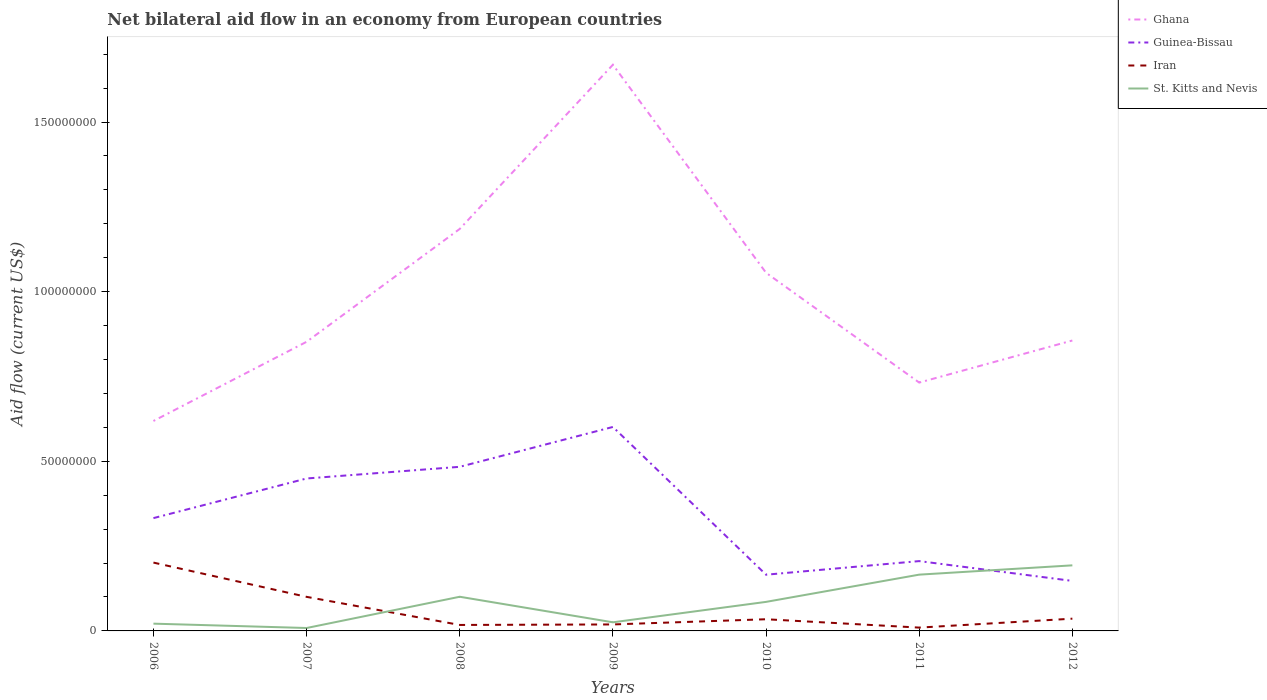How many different coloured lines are there?
Your response must be concise. 4. Does the line corresponding to Iran intersect with the line corresponding to Ghana?
Give a very brief answer. No. Is the number of lines equal to the number of legend labels?
Keep it short and to the point. Yes. Across all years, what is the maximum net bilateral aid flow in Ghana?
Keep it short and to the point. 6.19e+07. In which year was the net bilateral aid flow in Guinea-Bissau maximum?
Offer a very short reply. 2012. What is the total net bilateral aid flow in Iran in the graph?
Keep it short and to the point. -1.70e+06. What is the difference between the highest and the second highest net bilateral aid flow in Ghana?
Your answer should be compact. 1.05e+08. Is the net bilateral aid flow in Iran strictly greater than the net bilateral aid flow in Ghana over the years?
Your response must be concise. Yes. How many lines are there?
Offer a very short reply. 4. What is the difference between two consecutive major ticks on the Y-axis?
Offer a very short reply. 5.00e+07. Where does the legend appear in the graph?
Ensure brevity in your answer.  Top right. How many legend labels are there?
Provide a succinct answer. 4. What is the title of the graph?
Your response must be concise. Net bilateral aid flow in an economy from European countries. Does "Guam" appear as one of the legend labels in the graph?
Offer a very short reply. No. What is the label or title of the X-axis?
Ensure brevity in your answer.  Years. What is the label or title of the Y-axis?
Your answer should be very brief. Aid flow (current US$). What is the Aid flow (current US$) in Ghana in 2006?
Provide a short and direct response. 6.19e+07. What is the Aid flow (current US$) of Guinea-Bissau in 2006?
Make the answer very short. 3.32e+07. What is the Aid flow (current US$) in Iran in 2006?
Offer a very short reply. 2.01e+07. What is the Aid flow (current US$) in St. Kitts and Nevis in 2006?
Keep it short and to the point. 2.14e+06. What is the Aid flow (current US$) in Ghana in 2007?
Make the answer very short. 8.52e+07. What is the Aid flow (current US$) in Guinea-Bissau in 2007?
Make the answer very short. 4.49e+07. What is the Aid flow (current US$) of Iran in 2007?
Give a very brief answer. 1.00e+07. What is the Aid flow (current US$) of St. Kitts and Nevis in 2007?
Offer a terse response. 8.60e+05. What is the Aid flow (current US$) in Ghana in 2008?
Make the answer very short. 1.18e+08. What is the Aid flow (current US$) in Guinea-Bissau in 2008?
Provide a succinct answer. 4.84e+07. What is the Aid flow (current US$) in Iran in 2008?
Make the answer very short. 1.76e+06. What is the Aid flow (current US$) of St. Kitts and Nevis in 2008?
Offer a very short reply. 1.01e+07. What is the Aid flow (current US$) in Ghana in 2009?
Give a very brief answer. 1.67e+08. What is the Aid flow (current US$) of Guinea-Bissau in 2009?
Your answer should be compact. 6.01e+07. What is the Aid flow (current US$) of Iran in 2009?
Your response must be concise. 1.91e+06. What is the Aid flow (current US$) of St. Kitts and Nevis in 2009?
Provide a succinct answer. 2.54e+06. What is the Aid flow (current US$) of Ghana in 2010?
Offer a very short reply. 1.06e+08. What is the Aid flow (current US$) in Guinea-Bissau in 2010?
Offer a very short reply. 1.66e+07. What is the Aid flow (current US$) in Iran in 2010?
Keep it short and to the point. 3.44e+06. What is the Aid flow (current US$) of St. Kitts and Nevis in 2010?
Offer a terse response. 8.56e+06. What is the Aid flow (current US$) in Ghana in 2011?
Provide a short and direct response. 7.32e+07. What is the Aid flow (current US$) in Guinea-Bissau in 2011?
Make the answer very short. 2.06e+07. What is the Aid flow (current US$) in Iran in 2011?
Give a very brief answer. 9.80e+05. What is the Aid flow (current US$) in St. Kitts and Nevis in 2011?
Keep it short and to the point. 1.66e+07. What is the Aid flow (current US$) of Ghana in 2012?
Make the answer very short. 8.56e+07. What is the Aid flow (current US$) of Guinea-Bissau in 2012?
Make the answer very short. 1.47e+07. What is the Aid flow (current US$) in Iran in 2012?
Offer a terse response. 3.61e+06. What is the Aid flow (current US$) of St. Kitts and Nevis in 2012?
Make the answer very short. 1.93e+07. Across all years, what is the maximum Aid flow (current US$) in Ghana?
Provide a short and direct response. 1.67e+08. Across all years, what is the maximum Aid flow (current US$) of Guinea-Bissau?
Make the answer very short. 6.01e+07. Across all years, what is the maximum Aid flow (current US$) of Iran?
Your response must be concise. 2.01e+07. Across all years, what is the maximum Aid flow (current US$) in St. Kitts and Nevis?
Your answer should be compact. 1.93e+07. Across all years, what is the minimum Aid flow (current US$) of Ghana?
Give a very brief answer. 6.19e+07. Across all years, what is the minimum Aid flow (current US$) of Guinea-Bissau?
Provide a short and direct response. 1.47e+07. Across all years, what is the minimum Aid flow (current US$) of Iran?
Offer a very short reply. 9.80e+05. Across all years, what is the minimum Aid flow (current US$) in St. Kitts and Nevis?
Offer a very short reply. 8.60e+05. What is the total Aid flow (current US$) in Ghana in the graph?
Provide a short and direct response. 6.97e+08. What is the total Aid flow (current US$) in Guinea-Bissau in the graph?
Your response must be concise. 2.39e+08. What is the total Aid flow (current US$) of Iran in the graph?
Offer a terse response. 4.19e+07. What is the total Aid flow (current US$) of St. Kitts and Nevis in the graph?
Your answer should be compact. 6.01e+07. What is the difference between the Aid flow (current US$) in Ghana in 2006 and that in 2007?
Provide a short and direct response. -2.33e+07. What is the difference between the Aid flow (current US$) in Guinea-Bissau in 2006 and that in 2007?
Make the answer very short. -1.17e+07. What is the difference between the Aid flow (current US$) in Iran in 2006 and that in 2007?
Your answer should be compact. 1.01e+07. What is the difference between the Aid flow (current US$) in St. Kitts and Nevis in 2006 and that in 2007?
Provide a succinct answer. 1.28e+06. What is the difference between the Aid flow (current US$) in Ghana in 2006 and that in 2008?
Provide a short and direct response. -5.66e+07. What is the difference between the Aid flow (current US$) in Guinea-Bissau in 2006 and that in 2008?
Your response must be concise. -1.51e+07. What is the difference between the Aid flow (current US$) of Iran in 2006 and that in 2008?
Give a very brief answer. 1.84e+07. What is the difference between the Aid flow (current US$) of St. Kitts and Nevis in 2006 and that in 2008?
Provide a succinct answer. -7.93e+06. What is the difference between the Aid flow (current US$) in Ghana in 2006 and that in 2009?
Your response must be concise. -1.05e+08. What is the difference between the Aid flow (current US$) in Guinea-Bissau in 2006 and that in 2009?
Give a very brief answer. -2.69e+07. What is the difference between the Aid flow (current US$) of Iran in 2006 and that in 2009?
Give a very brief answer. 1.82e+07. What is the difference between the Aid flow (current US$) of St. Kitts and Nevis in 2006 and that in 2009?
Keep it short and to the point. -4.00e+05. What is the difference between the Aid flow (current US$) of Ghana in 2006 and that in 2010?
Offer a terse response. -4.37e+07. What is the difference between the Aid flow (current US$) in Guinea-Bissau in 2006 and that in 2010?
Ensure brevity in your answer.  1.67e+07. What is the difference between the Aid flow (current US$) in Iran in 2006 and that in 2010?
Provide a succinct answer. 1.67e+07. What is the difference between the Aid flow (current US$) of St. Kitts and Nevis in 2006 and that in 2010?
Ensure brevity in your answer.  -6.42e+06. What is the difference between the Aid flow (current US$) in Ghana in 2006 and that in 2011?
Your response must be concise. -1.13e+07. What is the difference between the Aid flow (current US$) in Guinea-Bissau in 2006 and that in 2011?
Provide a succinct answer. 1.27e+07. What is the difference between the Aid flow (current US$) of Iran in 2006 and that in 2011?
Your answer should be very brief. 1.92e+07. What is the difference between the Aid flow (current US$) of St. Kitts and Nevis in 2006 and that in 2011?
Give a very brief answer. -1.44e+07. What is the difference between the Aid flow (current US$) in Ghana in 2006 and that in 2012?
Offer a terse response. -2.37e+07. What is the difference between the Aid flow (current US$) in Guinea-Bissau in 2006 and that in 2012?
Give a very brief answer. 1.85e+07. What is the difference between the Aid flow (current US$) in Iran in 2006 and that in 2012?
Your answer should be very brief. 1.65e+07. What is the difference between the Aid flow (current US$) in St. Kitts and Nevis in 2006 and that in 2012?
Make the answer very short. -1.72e+07. What is the difference between the Aid flow (current US$) in Ghana in 2007 and that in 2008?
Your answer should be very brief. -3.33e+07. What is the difference between the Aid flow (current US$) of Guinea-Bissau in 2007 and that in 2008?
Your response must be concise. -3.44e+06. What is the difference between the Aid flow (current US$) in Iran in 2007 and that in 2008?
Keep it short and to the point. 8.28e+06. What is the difference between the Aid flow (current US$) of St. Kitts and Nevis in 2007 and that in 2008?
Your answer should be compact. -9.21e+06. What is the difference between the Aid flow (current US$) of Ghana in 2007 and that in 2009?
Ensure brevity in your answer.  -8.17e+07. What is the difference between the Aid flow (current US$) of Guinea-Bissau in 2007 and that in 2009?
Ensure brevity in your answer.  -1.52e+07. What is the difference between the Aid flow (current US$) of Iran in 2007 and that in 2009?
Your answer should be very brief. 8.13e+06. What is the difference between the Aid flow (current US$) in St. Kitts and Nevis in 2007 and that in 2009?
Provide a short and direct response. -1.68e+06. What is the difference between the Aid flow (current US$) in Ghana in 2007 and that in 2010?
Your response must be concise. -2.03e+07. What is the difference between the Aid flow (current US$) in Guinea-Bissau in 2007 and that in 2010?
Provide a short and direct response. 2.84e+07. What is the difference between the Aid flow (current US$) in Iran in 2007 and that in 2010?
Your answer should be very brief. 6.60e+06. What is the difference between the Aid flow (current US$) in St. Kitts and Nevis in 2007 and that in 2010?
Keep it short and to the point. -7.70e+06. What is the difference between the Aid flow (current US$) in Ghana in 2007 and that in 2011?
Keep it short and to the point. 1.20e+07. What is the difference between the Aid flow (current US$) of Guinea-Bissau in 2007 and that in 2011?
Your answer should be compact. 2.44e+07. What is the difference between the Aid flow (current US$) in Iran in 2007 and that in 2011?
Provide a succinct answer. 9.06e+06. What is the difference between the Aid flow (current US$) in St. Kitts and Nevis in 2007 and that in 2011?
Provide a succinct answer. -1.57e+07. What is the difference between the Aid flow (current US$) of Ghana in 2007 and that in 2012?
Your response must be concise. -3.80e+05. What is the difference between the Aid flow (current US$) of Guinea-Bissau in 2007 and that in 2012?
Give a very brief answer. 3.02e+07. What is the difference between the Aid flow (current US$) of Iran in 2007 and that in 2012?
Your answer should be very brief. 6.43e+06. What is the difference between the Aid flow (current US$) in St. Kitts and Nevis in 2007 and that in 2012?
Ensure brevity in your answer.  -1.85e+07. What is the difference between the Aid flow (current US$) of Ghana in 2008 and that in 2009?
Keep it short and to the point. -4.84e+07. What is the difference between the Aid flow (current US$) in Guinea-Bissau in 2008 and that in 2009?
Your answer should be compact. -1.18e+07. What is the difference between the Aid flow (current US$) in Iran in 2008 and that in 2009?
Your response must be concise. -1.50e+05. What is the difference between the Aid flow (current US$) of St. Kitts and Nevis in 2008 and that in 2009?
Your answer should be compact. 7.53e+06. What is the difference between the Aid flow (current US$) in Ghana in 2008 and that in 2010?
Ensure brevity in your answer.  1.29e+07. What is the difference between the Aid flow (current US$) of Guinea-Bissau in 2008 and that in 2010?
Give a very brief answer. 3.18e+07. What is the difference between the Aid flow (current US$) in Iran in 2008 and that in 2010?
Keep it short and to the point. -1.68e+06. What is the difference between the Aid flow (current US$) in St. Kitts and Nevis in 2008 and that in 2010?
Your answer should be compact. 1.51e+06. What is the difference between the Aid flow (current US$) of Ghana in 2008 and that in 2011?
Provide a short and direct response. 4.53e+07. What is the difference between the Aid flow (current US$) of Guinea-Bissau in 2008 and that in 2011?
Provide a short and direct response. 2.78e+07. What is the difference between the Aid flow (current US$) in Iran in 2008 and that in 2011?
Provide a succinct answer. 7.80e+05. What is the difference between the Aid flow (current US$) in St. Kitts and Nevis in 2008 and that in 2011?
Make the answer very short. -6.52e+06. What is the difference between the Aid flow (current US$) in Ghana in 2008 and that in 2012?
Ensure brevity in your answer.  3.29e+07. What is the difference between the Aid flow (current US$) in Guinea-Bissau in 2008 and that in 2012?
Keep it short and to the point. 3.36e+07. What is the difference between the Aid flow (current US$) of Iran in 2008 and that in 2012?
Provide a short and direct response. -1.85e+06. What is the difference between the Aid flow (current US$) of St. Kitts and Nevis in 2008 and that in 2012?
Your response must be concise. -9.26e+06. What is the difference between the Aid flow (current US$) in Ghana in 2009 and that in 2010?
Your answer should be compact. 6.13e+07. What is the difference between the Aid flow (current US$) of Guinea-Bissau in 2009 and that in 2010?
Give a very brief answer. 4.36e+07. What is the difference between the Aid flow (current US$) of Iran in 2009 and that in 2010?
Your response must be concise. -1.53e+06. What is the difference between the Aid flow (current US$) in St. Kitts and Nevis in 2009 and that in 2010?
Your answer should be very brief. -6.02e+06. What is the difference between the Aid flow (current US$) of Ghana in 2009 and that in 2011?
Keep it short and to the point. 9.37e+07. What is the difference between the Aid flow (current US$) of Guinea-Bissau in 2009 and that in 2011?
Ensure brevity in your answer.  3.95e+07. What is the difference between the Aid flow (current US$) of Iran in 2009 and that in 2011?
Keep it short and to the point. 9.30e+05. What is the difference between the Aid flow (current US$) of St. Kitts and Nevis in 2009 and that in 2011?
Offer a terse response. -1.40e+07. What is the difference between the Aid flow (current US$) of Ghana in 2009 and that in 2012?
Offer a terse response. 8.13e+07. What is the difference between the Aid flow (current US$) of Guinea-Bissau in 2009 and that in 2012?
Ensure brevity in your answer.  4.54e+07. What is the difference between the Aid flow (current US$) in Iran in 2009 and that in 2012?
Provide a succinct answer. -1.70e+06. What is the difference between the Aid flow (current US$) of St. Kitts and Nevis in 2009 and that in 2012?
Offer a very short reply. -1.68e+07. What is the difference between the Aid flow (current US$) of Ghana in 2010 and that in 2011?
Provide a succinct answer. 3.24e+07. What is the difference between the Aid flow (current US$) of Guinea-Bissau in 2010 and that in 2011?
Your answer should be compact. -4.01e+06. What is the difference between the Aid flow (current US$) in Iran in 2010 and that in 2011?
Give a very brief answer. 2.46e+06. What is the difference between the Aid flow (current US$) in St. Kitts and Nevis in 2010 and that in 2011?
Offer a very short reply. -8.03e+06. What is the difference between the Aid flow (current US$) in Ghana in 2010 and that in 2012?
Ensure brevity in your answer.  2.00e+07. What is the difference between the Aid flow (current US$) of Guinea-Bissau in 2010 and that in 2012?
Your answer should be very brief. 1.83e+06. What is the difference between the Aid flow (current US$) in Iran in 2010 and that in 2012?
Your response must be concise. -1.70e+05. What is the difference between the Aid flow (current US$) in St. Kitts and Nevis in 2010 and that in 2012?
Provide a succinct answer. -1.08e+07. What is the difference between the Aid flow (current US$) in Ghana in 2011 and that in 2012?
Keep it short and to the point. -1.24e+07. What is the difference between the Aid flow (current US$) of Guinea-Bissau in 2011 and that in 2012?
Your answer should be very brief. 5.84e+06. What is the difference between the Aid flow (current US$) in Iran in 2011 and that in 2012?
Give a very brief answer. -2.63e+06. What is the difference between the Aid flow (current US$) of St. Kitts and Nevis in 2011 and that in 2012?
Give a very brief answer. -2.74e+06. What is the difference between the Aid flow (current US$) of Ghana in 2006 and the Aid flow (current US$) of Guinea-Bissau in 2007?
Offer a terse response. 1.70e+07. What is the difference between the Aid flow (current US$) of Ghana in 2006 and the Aid flow (current US$) of Iran in 2007?
Offer a very short reply. 5.18e+07. What is the difference between the Aid flow (current US$) in Ghana in 2006 and the Aid flow (current US$) in St. Kitts and Nevis in 2007?
Offer a very short reply. 6.10e+07. What is the difference between the Aid flow (current US$) in Guinea-Bissau in 2006 and the Aid flow (current US$) in Iran in 2007?
Ensure brevity in your answer.  2.32e+07. What is the difference between the Aid flow (current US$) of Guinea-Bissau in 2006 and the Aid flow (current US$) of St. Kitts and Nevis in 2007?
Ensure brevity in your answer.  3.24e+07. What is the difference between the Aid flow (current US$) of Iran in 2006 and the Aid flow (current US$) of St. Kitts and Nevis in 2007?
Your answer should be very brief. 1.93e+07. What is the difference between the Aid flow (current US$) of Ghana in 2006 and the Aid flow (current US$) of Guinea-Bissau in 2008?
Offer a very short reply. 1.35e+07. What is the difference between the Aid flow (current US$) of Ghana in 2006 and the Aid flow (current US$) of Iran in 2008?
Your answer should be very brief. 6.01e+07. What is the difference between the Aid flow (current US$) of Ghana in 2006 and the Aid flow (current US$) of St. Kitts and Nevis in 2008?
Your response must be concise. 5.18e+07. What is the difference between the Aid flow (current US$) in Guinea-Bissau in 2006 and the Aid flow (current US$) in Iran in 2008?
Make the answer very short. 3.15e+07. What is the difference between the Aid flow (current US$) in Guinea-Bissau in 2006 and the Aid flow (current US$) in St. Kitts and Nevis in 2008?
Offer a terse response. 2.32e+07. What is the difference between the Aid flow (current US$) in Iran in 2006 and the Aid flow (current US$) in St. Kitts and Nevis in 2008?
Give a very brief answer. 1.01e+07. What is the difference between the Aid flow (current US$) in Ghana in 2006 and the Aid flow (current US$) in Guinea-Bissau in 2009?
Your answer should be very brief. 1.76e+06. What is the difference between the Aid flow (current US$) of Ghana in 2006 and the Aid flow (current US$) of Iran in 2009?
Make the answer very short. 6.00e+07. What is the difference between the Aid flow (current US$) of Ghana in 2006 and the Aid flow (current US$) of St. Kitts and Nevis in 2009?
Make the answer very short. 5.93e+07. What is the difference between the Aid flow (current US$) of Guinea-Bissau in 2006 and the Aid flow (current US$) of Iran in 2009?
Your response must be concise. 3.13e+07. What is the difference between the Aid flow (current US$) in Guinea-Bissau in 2006 and the Aid flow (current US$) in St. Kitts and Nevis in 2009?
Ensure brevity in your answer.  3.07e+07. What is the difference between the Aid flow (current US$) in Iran in 2006 and the Aid flow (current US$) in St. Kitts and Nevis in 2009?
Your answer should be very brief. 1.76e+07. What is the difference between the Aid flow (current US$) of Ghana in 2006 and the Aid flow (current US$) of Guinea-Bissau in 2010?
Keep it short and to the point. 4.53e+07. What is the difference between the Aid flow (current US$) of Ghana in 2006 and the Aid flow (current US$) of Iran in 2010?
Your answer should be very brief. 5.84e+07. What is the difference between the Aid flow (current US$) in Ghana in 2006 and the Aid flow (current US$) in St. Kitts and Nevis in 2010?
Provide a succinct answer. 5.33e+07. What is the difference between the Aid flow (current US$) in Guinea-Bissau in 2006 and the Aid flow (current US$) in Iran in 2010?
Make the answer very short. 2.98e+07. What is the difference between the Aid flow (current US$) of Guinea-Bissau in 2006 and the Aid flow (current US$) of St. Kitts and Nevis in 2010?
Your response must be concise. 2.47e+07. What is the difference between the Aid flow (current US$) of Iran in 2006 and the Aid flow (current US$) of St. Kitts and Nevis in 2010?
Keep it short and to the point. 1.16e+07. What is the difference between the Aid flow (current US$) in Ghana in 2006 and the Aid flow (current US$) in Guinea-Bissau in 2011?
Provide a short and direct response. 4.13e+07. What is the difference between the Aid flow (current US$) in Ghana in 2006 and the Aid flow (current US$) in Iran in 2011?
Your response must be concise. 6.09e+07. What is the difference between the Aid flow (current US$) of Ghana in 2006 and the Aid flow (current US$) of St. Kitts and Nevis in 2011?
Your answer should be compact. 4.53e+07. What is the difference between the Aid flow (current US$) in Guinea-Bissau in 2006 and the Aid flow (current US$) in Iran in 2011?
Keep it short and to the point. 3.23e+07. What is the difference between the Aid flow (current US$) of Guinea-Bissau in 2006 and the Aid flow (current US$) of St. Kitts and Nevis in 2011?
Your response must be concise. 1.67e+07. What is the difference between the Aid flow (current US$) of Iran in 2006 and the Aid flow (current US$) of St. Kitts and Nevis in 2011?
Provide a short and direct response. 3.55e+06. What is the difference between the Aid flow (current US$) of Ghana in 2006 and the Aid flow (current US$) of Guinea-Bissau in 2012?
Make the answer very short. 4.71e+07. What is the difference between the Aid flow (current US$) in Ghana in 2006 and the Aid flow (current US$) in Iran in 2012?
Your response must be concise. 5.83e+07. What is the difference between the Aid flow (current US$) of Ghana in 2006 and the Aid flow (current US$) of St. Kitts and Nevis in 2012?
Give a very brief answer. 4.26e+07. What is the difference between the Aid flow (current US$) of Guinea-Bissau in 2006 and the Aid flow (current US$) of Iran in 2012?
Provide a succinct answer. 2.96e+07. What is the difference between the Aid flow (current US$) of Guinea-Bissau in 2006 and the Aid flow (current US$) of St. Kitts and Nevis in 2012?
Your answer should be very brief. 1.39e+07. What is the difference between the Aid flow (current US$) in Iran in 2006 and the Aid flow (current US$) in St. Kitts and Nevis in 2012?
Your response must be concise. 8.10e+05. What is the difference between the Aid flow (current US$) of Ghana in 2007 and the Aid flow (current US$) of Guinea-Bissau in 2008?
Your answer should be very brief. 3.68e+07. What is the difference between the Aid flow (current US$) in Ghana in 2007 and the Aid flow (current US$) in Iran in 2008?
Your answer should be compact. 8.35e+07. What is the difference between the Aid flow (current US$) of Ghana in 2007 and the Aid flow (current US$) of St. Kitts and Nevis in 2008?
Ensure brevity in your answer.  7.52e+07. What is the difference between the Aid flow (current US$) in Guinea-Bissau in 2007 and the Aid flow (current US$) in Iran in 2008?
Keep it short and to the point. 4.32e+07. What is the difference between the Aid flow (current US$) in Guinea-Bissau in 2007 and the Aid flow (current US$) in St. Kitts and Nevis in 2008?
Make the answer very short. 3.49e+07. What is the difference between the Aid flow (current US$) of Ghana in 2007 and the Aid flow (current US$) of Guinea-Bissau in 2009?
Offer a terse response. 2.51e+07. What is the difference between the Aid flow (current US$) of Ghana in 2007 and the Aid flow (current US$) of Iran in 2009?
Keep it short and to the point. 8.33e+07. What is the difference between the Aid flow (current US$) of Ghana in 2007 and the Aid flow (current US$) of St. Kitts and Nevis in 2009?
Make the answer very short. 8.27e+07. What is the difference between the Aid flow (current US$) in Guinea-Bissau in 2007 and the Aid flow (current US$) in Iran in 2009?
Offer a terse response. 4.30e+07. What is the difference between the Aid flow (current US$) of Guinea-Bissau in 2007 and the Aid flow (current US$) of St. Kitts and Nevis in 2009?
Keep it short and to the point. 4.24e+07. What is the difference between the Aid flow (current US$) of Iran in 2007 and the Aid flow (current US$) of St. Kitts and Nevis in 2009?
Make the answer very short. 7.50e+06. What is the difference between the Aid flow (current US$) of Ghana in 2007 and the Aid flow (current US$) of Guinea-Bissau in 2010?
Offer a terse response. 6.86e+07. What is the difference between the Aid flow (current US$) of Ghana in 2007 and the Aid flow (current US$) of Iran in 2010?
Provide a short and direct response. 8.18e+07. What is the difference between the Aid flow (current US$) of Ghana in 2007 and the Aid flow (current US$) of St. Kitts and Nevis in 2010?
Offer a terse response. 7.67e+07. What is the difference between the Aid flow (current US$) in Guinea-Bissau in 2007 and the Aid flow (current US$) in Iran in 2010?
Provide a succinct answer. 4.15e+07. What is the difference between the Aid flow (current US$) of Guinea-Bissau in 2007 and the Aid flow (current US$) of St. Kitts and Nevis in 2010?
Give a very brief answer. 3.64e+07. What is the difference between the Aid flow (current US$) of Iran in 2007 and the Aid flow (current US$) of St. Kitts and Nevis in 2010?
Provide a succinct answer. 1.48e+06. What is the difference between the Aid flow (current US$) in Ghana in 2007 and the Aid flow (current US$) in Guinea-Bissau in 2011?
Keep it short and to the point. 6.46e+07. What is the difference between the Aid flow (current US$) of Ghana in 2007 and the Aid flow (current US$) of Iran in 2011?
Your answer should be very brief. 8.42e+07. What is the difference between the Aid flow (current US$) in Ghana in 2007 and the Aid flow (current US$) in St. Kitts and Nevis in 2011?
Your response must be concise. 6.86e+07. What is the difference between the Aid flow (current US$) in Guinea-Bissau in 2007 and the Aid flow (current US$) in Iran in 2011?
Your answer should be very brief. 4.40e+07. What is the difference between the Aid flow (current US$) of Guinea-Bissau in 2007 and the Aid flow (current US$) of St. Kitts and Nevis in 2011?
Your response must be concise. 2.83e+07. What is the difference between the Aid flow (current US$) of Iran in 2007 and the Aid flow (current US$) of St. Kitts and Nevis in 2011?
Your response must be concise. -6.55e+06. What is the difference between the Aid flow (current US$) in Ghana in 2007 and the Aid flow (current US$) in Guinea-Bissau in 2012?
Your answer should be compact. 7.05e+07. What is the difference between the Aid flow (current US$) in Ghana in 2007 and the Aid flow (current US$) in Iran in 2012?
Your response must be concise. 8.16e+07. What is the difference between the Aid flow (current US$) in Ghana in 2007 and the Aid flow (current US$) in St. Kitts and Nevis in 2012?
Offer a very short reply. 6.59e+07. What is the difference between the Aid flow (current US$) of Guinea-Bissau in 2007 and the Aid flow (current US$) of Iran in 2012?
Offer a terse response. 4.13e+07. What is the difference between the Aid flow (current US$) of Guinea-Bissau in 2007 and the Aid flow (current US$) of St. Kitts and Nevis in 2012?
Provide a short and direct response. 2.56e+07. What is the difference between the Aid flow (current US$) in Iran in 2007 and the Aid flow (current US$) in St. Kitts and Nevis in 2012?
Give a very brief answer. -9.29e+06. What is the difference between the Aid flow (current US$) of Ghana in 2008 and the Aid flow (current US$) of Guinea-Bissau in 2009?
Make the answer very short. 5.84e+07. What is the difference between the Aid flow (current US$) of Ghana in 2008 and the Aid flow (current US$) of Iran in 2009?
Your answer should be very brief. 1.17e+08. What is the difference between the Aid flow (current US$) of Ghana in 2008 and the Aid flow (current US$) of St. Kitts and Nevis in 2009?
Your answer should be compact. 1.16e+08. What is the difference between the Aid flow (current US$) of Guinea-Bissau in 2008 and the Aid flow (current US$) of Iran in 2009?
Make the answer very short. 4.65e+07. What is the difference between the Aid flow (current US$) in Guinea-Bissau in 2008 and the Aid flow (current US$) in St. Kitts and Nevis in 2009?
Give a very brief answer. 4.58e+07. What is the difference between the Aid flow (current US$) of Iran in 2008 and the Aid flow (current US$) of St. Kitts and Nevis in 2009?
Your answer should be very brief. -7.80e+05. What is the difference between the Aid flow (current US$) in Ghana in 2008 and the Aid flow (current US$) in Guinea-Bissau in 2010?
Provide a succinct answer. 1.02e+08. What is the difference between the Aid flow (current US$) in Ghana in 2008 and the Aid flow (current US$) in Iran in 2010?
Ensure brevity in your answer.  1.15e+08. What is the difference between the Aid flow (current US$) of Ghana in 2008 and the Aid flow (current US$) of St. Kitts and Nevis in 2010?
Ensure brevity in your answer.  1.10e+08. What is the difference between the Aid flow (current US$) in Guinea-Bissau in 2008 and the Aid flow (current US$) in Iran in 2010?
Provide a succinct answer. 4.49e+07. What is the difference between the Aid flow (current US$) of Guinea-Bissau in 2008 and the Aid flow (current US$) of St. Kitts and Nevis in 2010?
Provide a short and direct response. 3.98e+07. What is the difference between the Aid flow (current US$) in Iran in 2008 and the Aid flow (current US$) in St. Kitts and Nevis in 2010?
Provide a succinct answer. -6.80e+06. What is the difference between the Aid flow (current US$) in Ghana in 2008 and the Aid flow (current US$) in Guinea-Bissau in 2011?
Keep it short and to the point. 9.79e+07. What is the difference between the Aid flow (current US$) in Ghana in 2008 and the Aid flow (current US$) in Iran in 2011?
Ensure brevity in your answer.  1.18e+08. What is the difference between the Aid flow (current US$) in Ghana in 2008 and the Aid flow (current US$) in St. Kitts and Nevis in 2011?
Keep it short and to the point. 1.02e+08. What is the difference between the Aid flow (current US$) of Guinea-Bissau in 2008 and the Aid flow (current US$) of Iran in 2011?
Your response must be concise. 4.74e+07. What is the difference between the Aid flow (current US$) of Guinea-Bissau in 2008 and the Aid flow (current US$) of St. Kitts and Nevis in 2011?
Your response must be concise. 3.18e+07. What is the difference between the Aid flow (current US$) in Iran in 2008 and the Aid flow (current US$) in St. Kitts and Nevis in 2011?
Your response must be concise. -1.48e+07. What is the difference between the Aid flow (current US$) of Ghana in 2008 and the Aid flow (current US$) of Guinea-Bissau in 2012?
Make the answer very short. 1.04e+08. What is the difference between the Aid flow (current US$) in Ghana in 2008 and the Aid flow (current US$) in Iran in 2012?
Keep it short and to the point. 1.15e+08. What is the difference between the Aid flow (current US$) of Ghana in 2008 and the Aid flow (current US$) of St. Kitts and Nevis in 2012?
Your response must be concise. 9.92e+07. What is the difference between the Aid flow (current US$) of Guinea-Bissau in 2008 and the Aid flow (current US$) of Iran in 2012?
Offer a terse response. 4.48e+07. What is the difference between the Aid flow (current US$) in Guinea-Bissau in 2008 and the Aid flow (current US$) in St. Kitts and Nevis in 2012?
Provide a short and direct response. 2.90e+07. What is the difference between the Aid flow (current US$) of Iran in 2008 and the Aid flow (current US$) of St. Kitts and Nevis in 2012?
Ensure brevity in your answer.  -1.76e+07. What is the difference between the Aid flow (current US$) in Ghana in 2009 and the Aid flow (current US$) in Guinea-Bissau in 2010?
Provide a short and direct response. 1.50e+08. What is the difference between the Aid flow (current US$) of Ghana in 2009 and the Aid flow (current US$) of Iran in 2010?
Your response must be concise. 1.63e+08. What is the difference between the Aid flow (current US$) in Ghana in 2009 and the Aid flow (current US$) in St. Kitts and Nevis in 2010?
Your answer should be very brief. 1.58e+08. What is the difference between the Aid flow (current US$) in Guinea-Bissau in 2009 and the Aid flow (current US$) in Iran in 2010?
Provide a short and direct response. 5.67e+07. What is the difference between the Aid flow (current US$) of Guinea-Bissau in 2009 and the Aid flow (current US$) of St. Kitts and Nevis in 2010?
Your answer should be very brief. 5.16e+07. What is the difference between the Aid flow (current US$) in Iran in 2009 and the Aid flow (current US$) in St. Kitts and Nevis in 2010?
Make the answer very short. -6.65e+06. What is the difference between the Aid flow (current US$) in Ghana in 2009 and the Aid flow (current US$) in Guinea-Bissau in 2011?
Your answer should be very brief. 1.46e+08. What is the difference between the Aid flow (current US$) of Ghana in 2009 and the Aid flow (current US$) of Iran in 2011?
Make the answer very short. 1.66e+08. What is the difference between the Aid flow (current US$) in Ghana in 2009 and the Aid flow (current US$) in St. Kitts and Nevis in 2011?
Provide a short and direct response. 1.50e+08. What is the difference between the Aid flow (current US$) in Guinea-Bissau in 2009 and the Aid flow (current US$) in Iran in 2011?
Your answer should be compact. 5.91e+07. What is the difference between the Aid flow (current US$) of Guinea-Bissau in 2009 and the Aid flow (current US$) of St. Kitts and Nevis in 2011?
Give a very brief answer. 4.35e+07. What is the difference between the Aid flow (current US$) in Iran in 2009 and the Aid flow (current US$) in St. Kitts and Nevis in 2011?
Ensure brevity in your answer.  -1.47e+07. What is the difference between the Aid flow (current US$) of Ghana in 2009 and the Aid flow (current US$) of Guinea-Bissau in 2012?
Your answer should be compact. 1.52e+08. What is the difference between the Aid flow (current US$) of Ghana in 2009 and the Aid flow (current US$) of Iran in 2012?
Provide a succinct answer. 1.63e+08. What is the difference between the Aid flow (current US$) in Ghana in 2009 and the Aid flow (current US$) in St. Kitts and Nevis in 2012?
Give a very brief answer. 1.48e+08. What is the difference between the Aid flow (current US$) in Guinea-Bissau in 2009 and the Aid flow (current US$) in Iran in 2012?
Your answer should be compact. 5.65e+07. What is the difference between the Aid flow (current US$) of Guinea-Bissau in 2009 and the Aid flow (current US$) of St. Kitts and Nevis in 2012?
Keep it short and to the point. 4.08e+07. What is the difference between the Aid flow (current US$) in Iran in 2009 and the Aid flow (current US$) in St. Kitts and Nevis in 2012?
Offer a very short reply. -1.74e+07. What is the difference between the Aid flow (current US$) in Ghana in 2010 and the Aid flow (current US$) in Guinea-Bissau in 2011?
Offer a very short reply. 8.50e+07. What is the difference between the Aid flow (current US$) of Ghana in 2010 and the Aid flow (current US$) of Iran in 2011?
Provide a short and direct response. 1.05e+08. What is the difference between the Aid flow (current US$) of Ghana in 2010 and the Aid flow (current US$) of St. Kitts and Nevis in 2011?
Ensure brevity in your answer.  8.90e+07. What is the difference between the Aid flow (current US$) in Guinea-Bissau in 2010 and the Aid flow (current US$) in Iran in 2011?
Offer a very short reply. 1.56e+07. What is the difference between the Aid flow (current US$) of Guinea-Bissau in 2010 and the Aid flow (current US$) of St. Kitts and Nevis in 2011?
Ensure brevity in your answer.  -2.00e+04. What is the difference between the Aid flow (current US$) of Iran in 2010 and the Aid flow (current US$) of St. Kitts and Nevis in 2011?
Ensure brevity in your answer.  -1.32e+07. What is the difference between the Aid flow (current US$) of Ghana in 2010 and the Aid flow (current US$) of Guinea-Bissau in 2012?
Provide a short and direct response. 9.08e+07. What is the difference between the Aid flow (current US$) in Ghana in 2010 and the Aid flow (current US$) in Iran in 2012?
Your answer should be compact. 1.02e+08. What is the difference between the Aid flow (current US$) of Ghana in 2010 and the Aid flow (current US$) of St. Kitts and Nevis in 2012?
Keep it short and to the point. 8.62e+07. What is the difference between the Aid flow (current US$) of Guinea-Bissau in 2010 and the Aid flow (current US$) of Iran in 2012?
Provide a succinct answer. 1.30e+07. What is the difference between the Aid flow (current US$) of Guinea-Bissau in 2010 and the Aid flow (current US$) of St. Kitts and Nevis in 2012?
Give a very brief answer. -2.76e+06. What is the difference between the Aid flow (current US$) in Iran in 2010 and the Aid flow (current US$) in St. Kitts and Nevis in 2012?
Your answer should be very brief. -1.59e+07. What is the difference between the Aid flow (current US$) of Ghana in 2011 and the Aid flow (current US$) of Guinea-Bissau in 2012?
Offer a very short reply. 5.85e+07. What is the difference between the Aid flow (current US$) in Ghana in 2011 and the Aid flow (current US$) in Iran in 2012?
Your response must be concise. 6.96e+07. What is the difference between the Aid flow (current US$) of Ghana in 2011 and the Aid flow (current US$) of St. Kitts and Nevis in 2012?
Offer a very short reply. 5.39e+07. What is the difference between the Aid flow (current US$) of Guinea-Bissau in 2011 and the Aid flow (current US$) of Iran in 2012?
Provide a short and direct response. 1.70e+07. What is the difference between the Aid flow (current US$) in Guinea-Bissau in 2011 and the Aid flow (current US$) in St. Kitts and Nevis in 2012?
Your answer should be very brief. 1.25e+06. What is the difference between the Aid flow (current US$) in Iran in 2011 and the Aid flow (current US$) in St. Kitts and Nevis in 2012?
Offer a very short reply. -1.84e+07. What is the average Aid flow (current US$) in Ghana per year?
Make the answer very short. 9.95e+07. What is the average Aid flow (current US$) in Guinea-Bissau per year?
Your response must be concise. 3.41e+07. What is the average Aid flow (current US$) of Iran per year?
Your answer should be very brief. 5.98e+06. What is the average Aid flow (current US$) of St. Kitts and Nevis per year?
Your answer should be very brief. 8.58e+06. In the year 2006, what is the difference between the Aid flow (current US$) in Ghana and Aid flow (current US$) in Guinea-Bissau?
Give a very brief answer. 2.86e+07. In the year 2006, what is the difference between the Aid flow (current US$) of Ghana and Aid flow (current US$) of Iran?
Provide a short and direct response. 4.17e+07. In the year 2006, what is the difference between the Aid flow (current US$) in Ghana and Aid flow (current US$) in St. Kitts and Nevis?
Keep it short and to the point. 5.97e+07. In the year 2006, what is the difference between the Aid flow (current US$) of Guinea-Bissau and Aid flow (current US$) of Iran?
Ensure brevity in your answer.  1.31e+07. In the year 2006, what is the difference between the Aid flow (current US$) in Guinea-Bissau and Aid flow (current US$) in St. Kitts and Nevis?
Ensure brevity in your answer.  3.11e+07. In the year 2006, what is the difference between the Aid flow (current US$) of Iran and Aid flow (current US$) of St. Kitts and Nevis?
Provide a succinct answer. 1.80e+07. In the year 2007, what is the difference between the Aid flow (current US$) of Ghana and Aid flow (current US$) of Guinea-Bissau?
Your answer should be compact. 4.03e+07. In the year 2007, what is the difference between the Aid flow (current US$) in Ghana and Aid flow (current US$) in Iran?
Your response must be concise. 7.52e+07. In the year 2007, what is the difference between the Aid flow (current US$) in Ghana and Aid flow (current US$) in St. Kitts and Nevis?
Ensure brevity in your answer.  8.44e+07. In the year 2007, what is the difference between the Aid flow (current US$) of Guinea-Bissau and Aid flow (current US$) of Iran?
Offer a terse response. 3.49e+07. In the year 2007, what is the difference between the Aid flow (current US$) of Guinea-Bissau and Aid flow (current US$) of St. Kitts and Nevis?
Give a very brief answer. 4.41e+07. In the year 2007, what is the difference between the Aid flow (current US$) in Iran and Aid flow (current US$) in St. Kitts and Nevis?
Keep it short and to the point. 9.18e+06. In the year 2008, what is the difference between the Aid flow (current US$) of Ghana and Aid flow (current US$) of Guinea-Bissau?
Make the answer very short. 7.01e+07. In the year 2008, what is the difference between the Aid flow (current US$) in Ghana and Aid flow (current US$) in Iran?
Offer a very short reply. 1.17e+08. In the year 2008, what is the difference between the Aid flow (current US$) of Ghana and Aid flow (current US$) of St. Kitts and Nevis?
Ensure brevity in your answer.  1.08e+08. In the year 2008, what is the difference between the Aid flow (current US$) of Guinea-Bissau and Aid flow (current US$) of Iran?
Give a very brief answer. 4.66e+07. In the year 2008, what is the difference between the Aid flow (current US$) in Guinea-Bissau and Aid flow (current US$) in St. Kitts and Nevis?
Provide a short and direct response. 3.83e+07. In the year 2008, what is the difference between the Aid flow (current US$) in Iran and Aid flow (current US$) in St. Kitts and Nevis?
Provide a succinct answer. -8.31e+06. In the year 2009, what is the difference between the Aid flow (current US$) in Ghana and Aid flow (current US$) in Guinea-Bissau?
Provide a succinct answer. 1.07e+08. In the year 2009, what is the difference between the Aid flow (current US$) of Ghana and Aid flow (current US$) of Iran?
Your response must be concise. 1.65e+08. In the year 2009, what is the difference between the Aid flow (current US$) in Ghana and Aid flow (current US$) in St. Kitts and Nevis?
Your answer should be very brief. 1.64e+08. In the year 2009, what is the difference between the Aid flow (current US$) of Guinea-Bissau and Aid flow (current US$) of Iran?
Provide a succinct answer. 5.82e+07. In the year 2009, what is the difference between the Aid flow (current US$) in Guinea-Bissau and Aid flow (current US$) in St. Kitts and Nevis?
Your answer should be very brief. 5.76e+07. In the year 2009, what is the difference between the Aid flow (current US$) of Iran and Aid flow (current US$) of St. Kitts and Nevis?
Keep it short and to the point. -6.30e+05. In the year 2010, what is the difference between the Aid flow (current US$) of Ghana and Aid flow (current US$) of Guinea-Bissau?
Your answer should be very brief. 8.90e+07. In the year 2010, what is the difference between the Aid flow (current US$) of Ghana and Aid flow (current US$) of Iran?
Give a very brief answer. 1.02e+08. In the year 2010, what is the difference between the Aid flow (current US$) of Ghana and Aid flow (current US$) of St. Kitts and Nevis?
Provide a succinct answer. 9.70e+07. In the year 2010, what is the difference between the Aid flow (current US$) of Guinea-Bissau and Aid flow (current US$) of Iran?
Your answer should be compact. 1.31e+07. In the year 2010, what is the difference between the Aid flow (current US$) of Guinea-Bissau and Aid flow (current US$) of St. Kitts and Nevis?
Provide a succinct answer. 8.01e+06. In the year 2010, what is the difference between the Aid flow (current US$) in Iran and Aid flow (current US$) in St. Kitts and Nevis?
Provide a succinct answer. -5.12e+06. In the year 2011, what is the difference between the Aid flow (current US$) of Ghana and Aid flow (current US$) of Guinea-Bissau?
Keep it short and to the point. 5.26e+07. In the year 2011, what is the difference between the Aid flow (current US$) in Ghana and Aid flow (current US$) in Iran?
Provide a succinct answer. 7.22e+07. In the year 2011, what is the difference between the Aid flow (current US$) in Ghana and Aid flow (current US$) in St. Kitts and Nevis?
Keep it short and to the point. 5.66e+07. In the year 2011, what is the difference between the Aid flow (current US$) in Guinea-Bissau and Aid flow (current US$) in Iran?
Provide a short and direct response. 1.96e+07. In the year 2011, what is the difference between the Aid flow (current US$) of Guinea-Bissau and Aid flow (current US$) of St. Kitts and Nevis?
Offer a very short reply. 3.99e+06. In the year 2011, what is the difference between the Aid flow (current US$) of Iran and Aid flow (current US$) of St. Kitts and Nevis?
Provide a short and direct response. -1.56e+07. In the year 2012, what is the difference between the Aid flow (current US$) in Ghana and Aid flow (current US$) in Guinea-Bissau?
Your answer should be very brief. 7.09e+07. In the year 2012, what is the difference between the Aid flow (current US$) of Ghana and Aid flow (current US$) of Iran?
Your answer should be very brief. 8.20e+07. In the year 2012, what is the difference between the Aid flow (current US$) in Ghana and Aid flow (current US$) in St. Kitts and Nevis?
Provide a short and direct response. 6.63e+07. In the year 2012, what is the difference between the Aid flow (current US$) in Guinea-Bissau and Aid flow (current US$) in Iran?
Your response must be concise. 1.11e+07. In the year 2012, what is the difference between the Aid flow (current US$) in Guinea-Bissau and Aid flow (current US$) in St. Kitts and Nevis?
Offer a very short reply. -4.59e+06. In the year 2012, what is the difference between the Aid flow (current US$) of Iran and Aid flow (current US$) of St. Kitts and Nevis?
Provide a succinct answer. -1.57e+07. What is the ratio of the Aid flow (current US$) of Ghana in 2006 to that in 2007?
Give a very brief answer. 0.73. What is the ratio of the Aid flow (current US$) of Guinea-Bissau in 2006 to that in 2007?
Provide a short and direct response. 0.74. What is the ratio of the Aid flow (current US$) in Iran in 2006 to that in 2007?
Give a very brief answer. 2.01. What is the ratio of the Aid flow (current US$) in St. Kitts and Nevis in 2006 to that in 2007?
Offer a terse response. 2.49. What is the ratio of the Aid flow (current US$) in Ghana in 2006 to that in 2008?
Your response must be concise. 0.52. What is the ratio of the Aid flow (current US$) of Guinea-Bissau in 2006 to that in 2008?
Offer a terse response. 0.69. What is the ratio of the Aid flow (current US$) in Iran in 2006 to that in 2008?
Your answer should be very brief. 11.44. What is the ratio of the Aid flow (current US$) of St. Kitts and Nevis in 2006 to that in 2008?
Give a very brief answer. 0.21. What is the ratio of the Aid flow (current US$) of Ghana in 2006 to that in 2009?
Make the answer very short. 0.37. What is the ratio of the Aid flow (current US$) in Guinea-Bissau in 2006 to that in 2009?
Ensure brevity in your answer.  0.55. What is the ratio of the Aid flow (current US$) of Iran in 2006 to that in 2009?
Give a very brief answer. 10.54. What is the ratio of the Aid flow (current US$) in St. Kitts and Nevis in 2006 to that in 2009?
Provide a succinct answer. 0.84. What is the ratio of the Aid flow (current US$) of Ghana in 2006 to that in 2010?
Give a very brief answer. 0.59. What is the ratio of the Aid flow (current US$) of Guinea-Bissau in 2006 to that in 2010?
Make the answer very short. 2.01. What is the ratio of the Aid flow (current US$) of Iran in 2006 to that in 2010?
Your response must be concise. 5.85. What is the ratio of the Aid flow (current US$) of St. Kitts and Nevis in 2006 to that in 2010?
Provide a succinct answer. 0.25. What is the ratio of the Aid flow (current US$) of Ghana in 2006 to that in 2011?
Offer a terse response. 0.85. What is the ratio of the Aid flow (current US$) of Guinea-Bissau in 2006 to that in 2011?
Provide a succinct answer. 1.62. What is the ratio of the Aid flow (current US$) of Iran in 2006 to that in 2011?
Your answer should be very brief. 20.55. What is the ratio of the Aid flow (current US$) in St. Kitts and Nevis in 2006 to that in 2011?
Your answer should be compact. 0.13. What is the ratio of the Aid flow (current US$) in Ghana in 2006 to that in 2012?
Make the answer very short. 0.72. What is the ratio of the Aid flow (current US$) in Guinea-Bissau in 2006 to that in 2012?
Provide a short and direct response. 2.26. What is the ratio of the Aid flow (current US$) in Iran in 2006 to that in 2012?
Make the answer very short. 5.58. What is the ratio of the Aid flow (current US$) in St. Kitts and Nevis in 2006 to that in 2012?
Your response must be concise. 0.11. What is the ratio of the Aid flow (current US$) of Ghana in 2007 to that in 2008?
Offer a terse response. 0.72. What is the ratio of the Aid flow (current US$) in Guinea-Bissau in 2007 to that in 2008?
Keep it short and to the point. 0.93. What is the ratio of the Aid flow (current US$) of Iran in 2007 to that in 2008?
Offer a terse response. 5.7. What is the ratio of the Aid flow (current US$) in St. Kitts and Nevis in 2007 to that in 2008?
Offer a terse response. 0.09. What is the ratio of the Aid flow (current US$) of Ghana in 2007 to that in 2009?
Make the answer very short. 0.51. What is the ratio of the Aid flow (current US$) in Guinea-Bissau in 2007 to that in 2009?
Your answer should be very brief. 0.75. What is the ratio of the Aid flow (current US$) of Iran in 2007 to that in 2009?
Your response must be concise. 5.26. What is the ratio of the Aid flow (current US$) of St. Kitts and Nevis in 2007 to that in 2009?
Ensure brevity in your answer.  0.34. What is the ratio of the Aid flow (current US$) in Ghana in 2007 to that in 2010?
Make the answer very short. 0.81. What is the ratio of the Aid flow (current US$) in Guinea-Bissau in 2007 to that in 2010?
Ensure brevity in your answer.  2.71. What is the ratio of the Aid flow (current US$) of Iran in 2007 to that in 2010?
Keep it short and to the point. 2.92. What is the ratio of the Aid flow (current US$) of St. Kitts and Nevis in 2007 to that in 2010?
Provide a succinct answer. 0.1. What is the ratio of the Aid flow (current US$) of Ghana in 2007 to that in 2011?
Offer a very short reply. 1.16. What is the ratio of the Aid flow (current US$) of Guinea-Bissau in 2007 to that in 2011?
Your response must be concise. 2.18. What is the ratio of the Aid flow (current US$) in Iran in 2007 to that in 2011?
Offer a very short reply. 10.24. What is the ratio of the Aid flow (current US$) of St. Kitts and Nevis in 2007 to that in 2011?
Keep it short and to the point. 0.05. What is the ratio of the Aid flow (current US$) of Guinea-Bissau in 2007 to that in 2012?
Provide a succinct answer. 3.05. What is the ratio of the Aid flow (current US$) of Iran in 2007 to that in 2012?
Keep it short and to the point. 2.78. What is the ratio of the Aid flow (current US$) in St. Kitts and Nevis in 2007 to that in 2012?
Provide a succinct answer. 0.04. What is the ratio of the Aid flow (current US$) in Ghana in 2008 to that in 2009?
Make the answer very short. 0.71. What is the ratio of the Aid flow (current US$) in Guinea-Bissau in 2008 to that in 2009?
Your answer should be very brief. 0.8. What is the ratio of the Aid flow (current US$) in Iran in 2008 to that in 2009?
Provide a short and direct response. 0.92. What is the ratio of the Aid flow (current US$) in St. Kitts and Nevis in 2008 to that in 2009?
Provide a short and direct response. 3.96. What is the ratio of the Aid flow (current US$) of Ghana in 2008 to that in 2010?
Provide a short and direct response. 1.12. What is the ratio of the Aid flow (current US$) in Guinea-Bissau in 2008 to that in 2010?
Provide a succinct answer. 2.92. What is the ratio of the Aid flow (current US$) in Iran in 2008 to that in 2010?
Ensure brevity in your answer.  0.51. What is the ratio of the Aid flow (current US$) of St. Kitts and Nevis in 2008 to that in 2010?
Give a very brief answer. 1.18. What is the ratio of the Aid flow (current US$) of Ghana in 2008 to that in 2011?
Make the answer very short. 1.62. What is the ratio of the Aid flow (current US$) in Guinea-Bissau in 2008 to that in 2011?
Give a very brief answer. 2.35. What is the ratio of the Aid flow (current US$) of Iran in 2008 to that in 2011?
Keep it short and to the point. 1.8. What is the ratio of the Aid flow (current US$) in St. Kitts and Nevis in 2008 to that in 2011?
Provide a short and direct response. 0.61. What is the ratio of the Aid flow (current US$) of Ghana in 2008 to that in 2012?
Offer a terse response. 1.38. What is the ratio of the Aid flow (current US$) in Guinea-Bissau in 2008 to that in 2012?
Keep it short and to the point. 3.28. What is the ratio of the Aid flow (current US$) of Iran in 2008 to that in 2012?
Provide a short and direct response. 0.49. What is the ratio of the Aid flow (current US$) of St. Kitts and Nevis in 2008 to that in 2012?
Make the answer very short. 0.52. What is the ratio of the Aid flow (current US$) in Ghana in 2009 to that in 2010?
Your answer should be compact. 1.58. What is the ratio of the Aid flow (current US$) in Guinea-Bissau in 2009 to that in 2010?
Provide a succinct answer. 3.63. What is the ratio of the Aid flow (current US$) of Iran in 2009 to that in 2010?
Your answer should be compact. 0.56. What is the ratio of the Aid flow (current US$) in St. Kitts and Nevis in 2009 to that in 2010?
Your answer should be very brief. 0.3. What is the ratio of the Aid flow (current US$) of Ghana in 2009 to that in 2011?
Your response must be concise. 2.28. What is the ratio of the Aid flow (current US$) in Guinea-Bissau in 2009 to that in 2011?
Give a very brief answer. 2.92. What is the ratio of the Aid flow (current US$) in Iran in 2009 to that in 2011?
Offer a terse response. 1.95. What is the ratio of the Aid flow (current US$) of St. Kitts and Nevis in 2009 to that in 2011?
Give a very brief answer. 0.15. What is the ratio of the Aid flow (current US$) of Ghana in 2009 to that in 2012?
Provide a succinct answer. 1.95. What is the ratio of the Aid flow (current US$) in Guinea-Bissau in 2009 to that in 2012?
Provide a short and direct response. 4.08. What is the ratio of the Aid flow (current US$) in Iran in 2009 to that in 2012?
Provide a short and direct response. 0.53. What is the ratio of the Aid flow (current US$) of St. Kitts and Nevis in 2009 to that in 2012?
Ensure brevity in your answer.  0.13. What is the ratio of the Aid flow (current US$) of Ghana in 2010 to that in 2011?
Your answer should be compact. 1.44. What is the ratio of the Aid flow (current US$) of Guinea-Bissau in 2010 to that in 2011?
Offer a terse response. 0.81. What is the ratio of the Aid flow (current US$) in Iran in 2010 to that in 2011?
Offer a terse response. 3.51. What is the ratio of the Aid flow (current US$) in St. Kitts and Nevis in 2010 to that in 2011?
Offer a very short reply. 0.52. What is the ratio of the Aid flow (current US$) of Ghana in 2010 to that in 2012?
Offer a very short reply. 1.23. What is the ratio of the Aid flow (current US$) of Guinea-Bissau in 2010 to that in 2012?
Keep it short and to the point. 1.12. What is the ratio of the Aid flow (current US$) of Iran in 2010 to that in 2012?
Your answer should be very brief. 0.95. What is the ratio of the Aid flow (current US$) in St. Kitts and Nevis in 2010 to that in 2012?
Keep it short and to the point. 0.44. What is the ratio of the Aid flow (current US$) in Ghana in 2011 to that in 2012?
Provide a succinct answer. 0.86. What is the ratio of the Aid flow (current US$) of Guinea-Bissau in 2011 to that in 2012?
Keep it short and to the point. 1.4. What is the ratio of the Aid flow (current US$) of Iran in 2011 to that in 2012?
Provide a succinct answer. 0.27. What is the ratio of the Aid flow (current US$) in St. Kitts and Nevis in 2011 to that in 2012?
Offer a very short reply. 0.86. What is the difference between the highest and the second highest Aid flow (current US$) in Ghana?
Your answer should be compact. 4.84e+07. What is the difference between the highest and the second highest Aid flow (current US$) of Guinea-Bissau?
Your answer should be compact. 1.18e+07. What is the difference between the highest and the second highest Aid flow (current US$) of Iran?
Your answer should be very brief. 1.01e+07. What is the difference between the highest and the second highest Aid flow (current US$) in St. Kitts and Nevis?
Provide a short and direct response. 2.74e+06. What is the difference between the highest and the lowest Aid flow (current US$) in Ghana?
Give a very brief answer. 1.05e+08. What is the difference between the highest and the lowest Aid flow (current US$) of Guinea-Bissau?
Keep it short and to the point. 4.54e+07. What is the difference between the highest and the lowest Aid flow (current US$) of Iran?
Your response must be concise. 1.92e+07. What is the difference between the highest and the lowest Aid flow (current US$) of St. Kitts and Nevis?
Provide a succinct answer. 1.85e+07. 